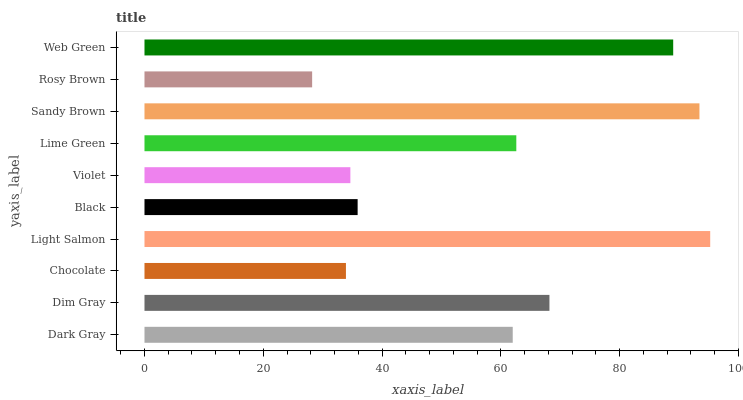Is Rosy Brown the minimum?
Answer yes or no. Yes. Is Light Salmon the maximum?
Answer yes or no. Yes. Is Dim Gray the minimum?
Answer yes or no. No. Is Dim Gray the maximum?
Answer yes or no. No. Is Dim Gray greater than Dark Gray?
Answer yes or no. Yes. Is Dark Gray less than Dim Gray?
Answer yes or no. Yes. Is Dark Gray greater than Dim Gray?
Answer yes or no. No. Is Dim Gray less than Dark Gray?
Answer yes or no. No. Is Lime Green the high median?
Answer yes or no. Yes. Is Dark Gray the low median?
Answer yes or no. Yes. Is Black the high median?
Answer yes or no. No. Is Violet the low median?
Answer yes or no. No. 